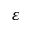<formula> <loc_0><loc_0><loc_500><loc_500>\varepsilon</formula> 